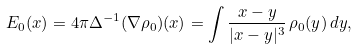<formula> <loc_0><loc_0><loc_500><loc_500>E _ { 0 } ( x ) = 4 \pi \Delta ^ { - 1 } ( \nabla \rho _ { 0 } ) ( x ) = \int \frac { x - y } { | x - y | ^ { 3 } } \, \rho _ { 0 } ( y ) \, d y ,</formula> 